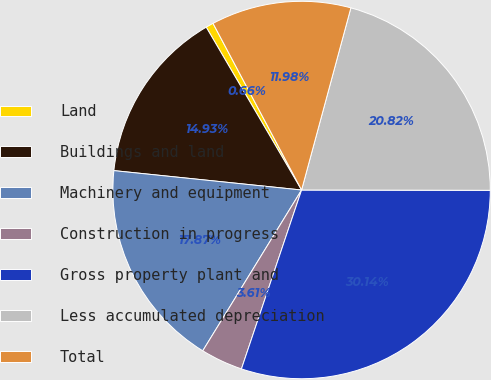Convert chart to OTSL. <chart><loc_0><loc_0><loc_500><loc_500><pie_chart><fcel>Land<fcel>Buildings and land<fcel>Machinery and equipment<fcel>Construction in progress<fcel>Gross property plant and<fcel>Less accumulated depreciation<fcel>Total<nl><fcel>0.66%<fcel>14.93%<fcel>17.87%<fcel>3.61%<fcel>30.14%<fcel>20.82%<fcel>11.98%<nl></chart> 